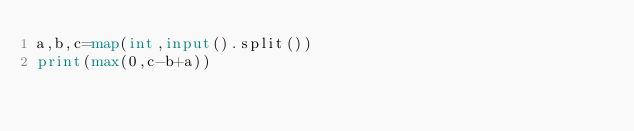Convert code to text. <code><loc_0><loc_0><loc_500><loc_500><_Python_>a,b,c=map(int,input().split())
print(max(0,c-b+a))
</code> 